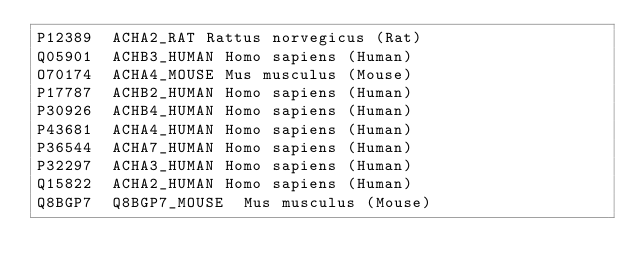Convert code to text. <code><loc_0><loc_0><loc_500><loc_500><_SQL_>P12389	ACHA2_RAT	Rattus norvegicus (Rat)
Q05901	ACHB3_HUMAN	Homo sapiens (Human)
O70174	ACHA4_MOUSE	Mus musculus (Mouse)
P17787	ACHB2_HUMAN	Homo sapiens (Human)
P30926	ACHB4_HUMAN	Homo sapiens (Human)
P43681	ACHA4_HUMAN	Homo sapiens (Human)
P36544	ACHA7_HUMAN	Homo sapiens (Human)
P32297	ACHA3_HUMAN	Homo sapiens (Human)
Q15822	ACHA2_HUMAN	Homo sapiens (Human)
Q8BGP7	Q8BGP7_MOUSE	Mus musculus (Mouse)
</code> 